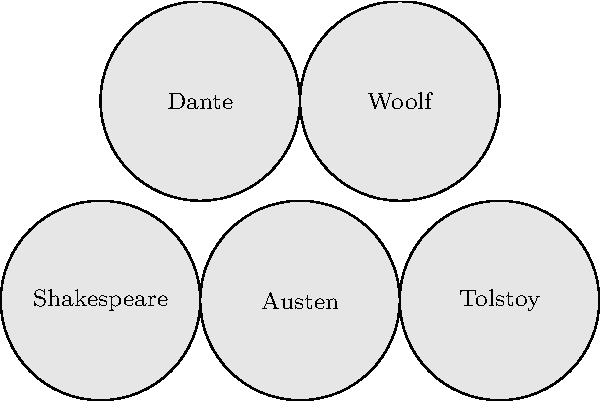Osservando i ritratti stilizzati degli autori, quale di questi non è considerato un autore classico della letteratura inglese? Per rispondere a questa domanda, dobbiamo analizzare ciascun autore rappresentato nei ritratti stilizzati:

1. Shakespeare: Autore inglese, considerato il più grande drammaturgo di lingua inglese.
2. Austen: Scrittrice inglese, famosa per i suoi romanzi ambientati nell'alta società inglese.
3. Tolstoy: Autore russo, noto per opere come "Guerra e Pace" e "Anna Karenina".
4. Dante: Poeta italiano, autore della "Divina Commedia".
5. Woolf: Scrittrice inglese modernista, autrice di opere come "Mrs. Dalloway" e "Gita al Faro".

Tra questi autori, Tolstoy e Dante non sono considerati classici della letteratura inglese. Tolstoy è un autore russo, mentre Dante è un poeta italiano. Tuttavia, poiché la domanda chiede di identificare un solo autore, la risposta più appropriata è Tolstoy, in quanto è l'unico autore russo rappresentato e non ha scritto in inglese, a differenza di Dante che, sebbene italiano, ha avuto una significativa influenza sulla letteratura inglese.
Answer: Tolstoy 